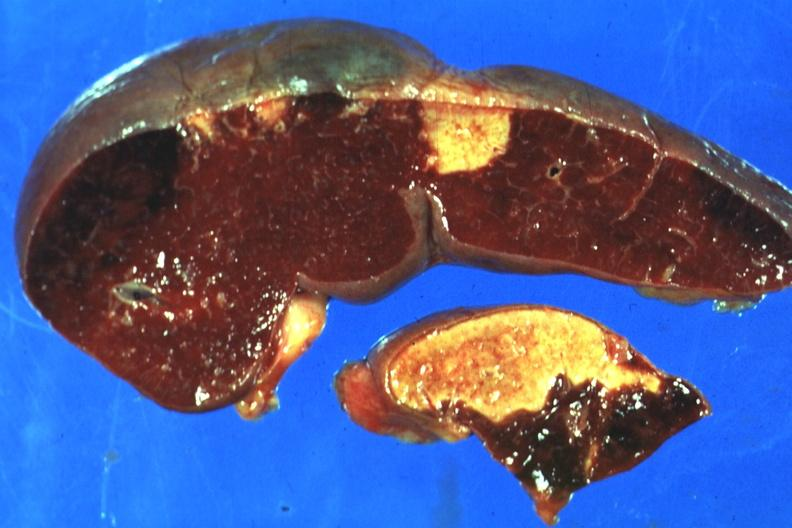what is excellent side with four infarcts shown?
Answer the question using a single word or phrase. Which are several days of age from nonbacterial endocarditis 